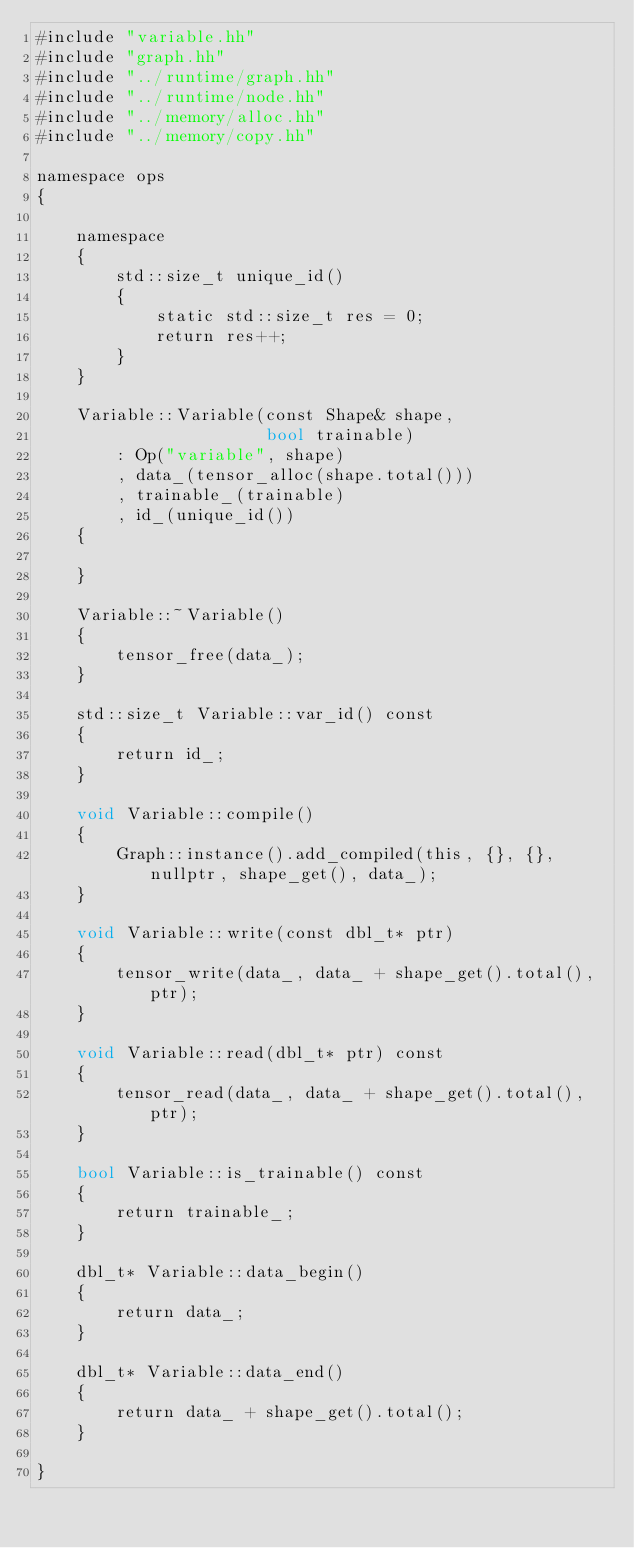<code> <loc_0><loc_0><loc_500><loc_500><_Cuda_>#include "variable.hh"
#include "graph.hh"
#include "../runtime/graph.hh"
#include "../runtime/node.hh"
#include "../memory/alloc.hh"
#include "../memory/copy.hh"

namespace ops
{

    namespace
    {
        std::size_t unique_id()
        {
            static std::size_t res = 0;
            return res++;
        }
    }

    Variable::Variable(const Shape& shape,
                       bool trainable)
        : Op("variable", shape)
        , data_(tensor_alloc(shape.total()))
        , trainable_(trainable)
        , id_(unique_id())
    {

    }

    Variable::~Variable()
    {
        tensor_free(data_);
    }

    std::size_t Variable::var_id() const
    {
        return id_;
    }

    void Variable::compile()
    {
        Graph::instance().add_compiled(this, {}, {}, nullptr, shape_get(), data_);
    }

    void Variable::write(const dbl_t* ptr)
    {
        tensor_write(data_, data_ + shape_get().total(), ptr);
    }
    
    void Variable::read(dbl_t* ptr) const
    {
        tensor_read(data_, data_ + shape_get().total(), ptr);
    }

    bool Variable::is_trainable() const
    {
        return trainable_;
    }

    dbl_t* Variable::data_begin()
    {
        return data_;
    }
    
    dbl_t* Variable::data_end()
    {
        return data_ + shape_get().total();
    }
    
}
</code> 